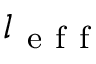Convert formula to latex. <formula><loc_0><loc_0><loc_500><loc_500>l _ { e f f }</formula> 